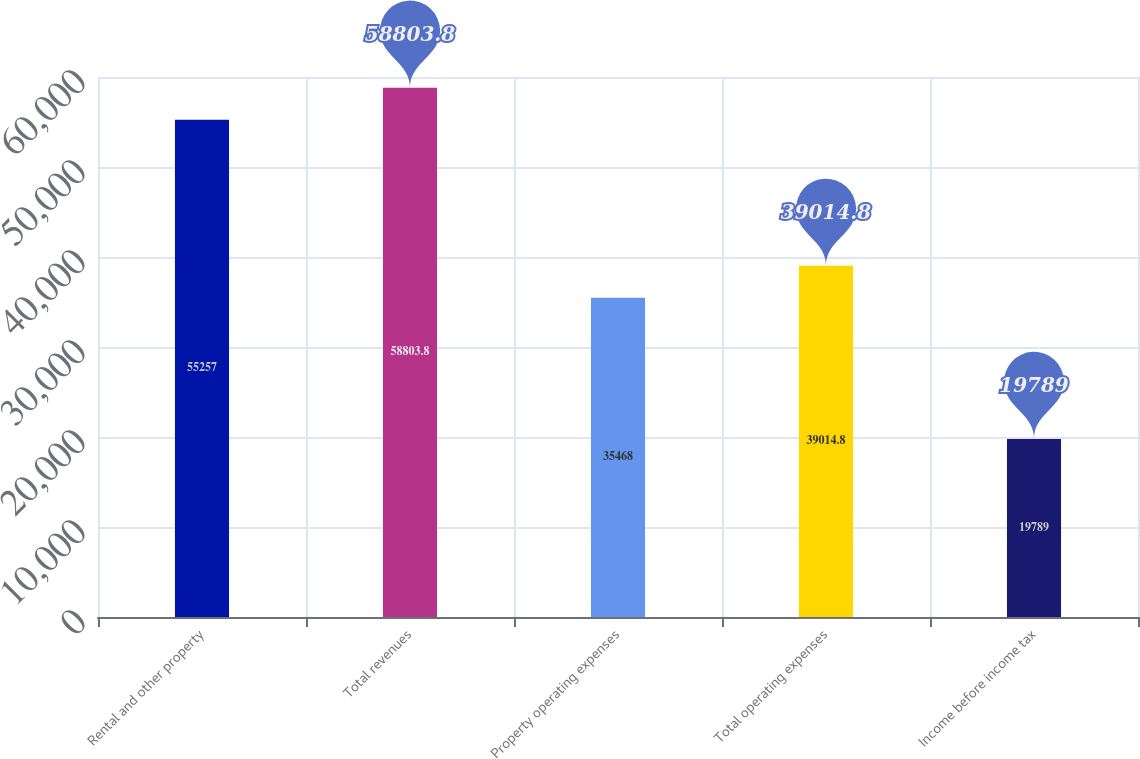Convert chart to OTSL. <chart><loc_0><loc_0><loc_500><loc_500><bar_chart><fcel>Rental and other property<fcel>Total revenues<fcel>Property operating expenses<fcel>Total operating expenses<fcel>Income before income tax<nl><fcel>55257<fcel>58803.8<fcel>35468<fcel>39014.8<fcel>19789<nl></chart> 